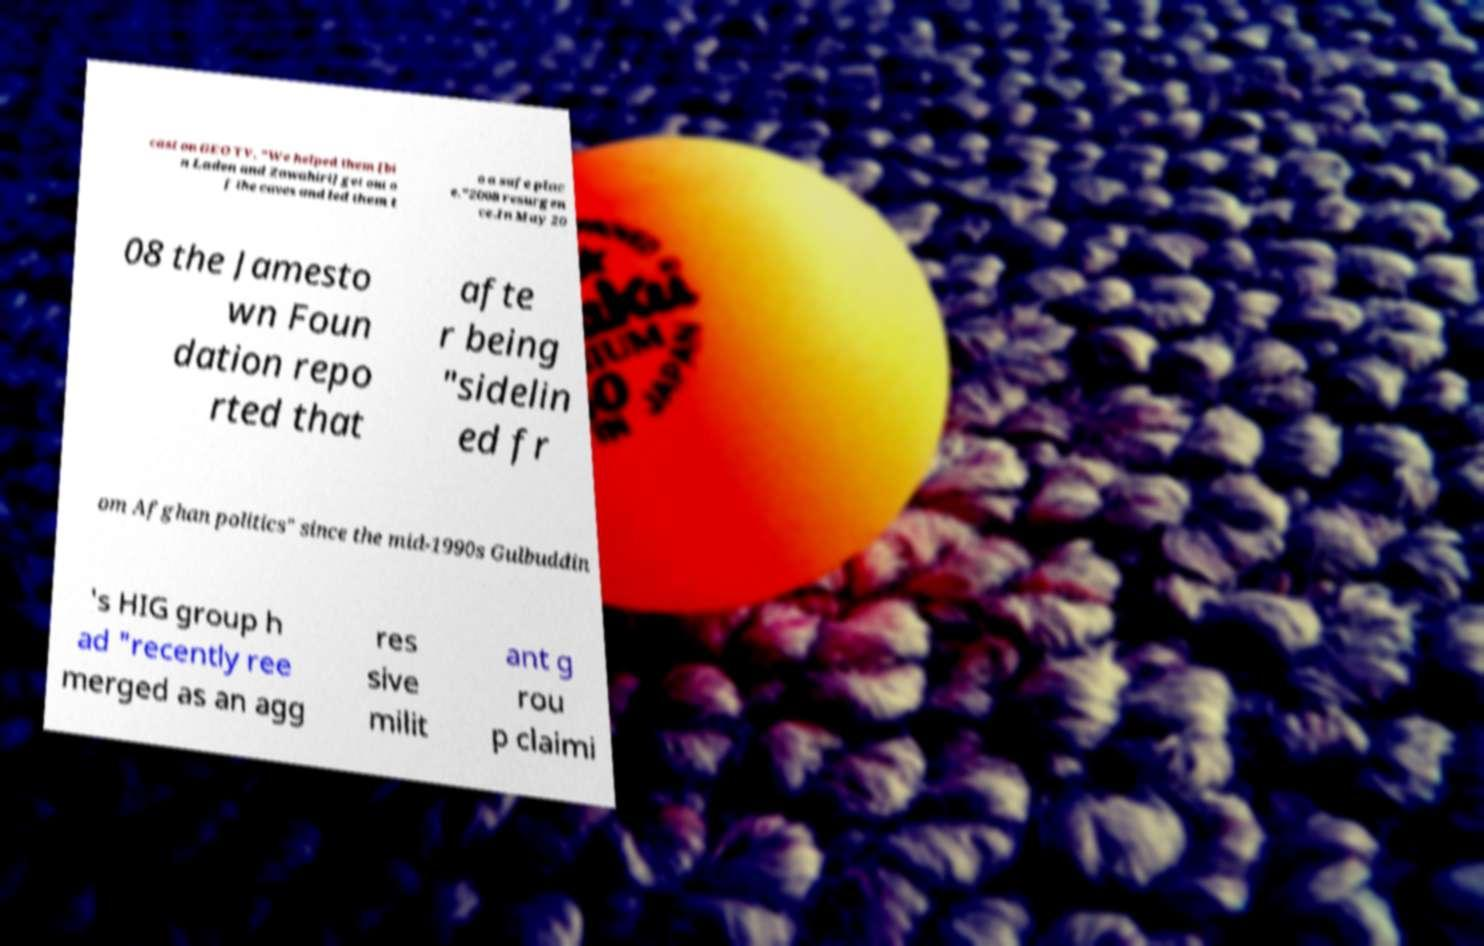Could you assist in decoding the text presented in this image and type it out clearly? cast on GEO TV, "We helped them [bi n Laden and Zawahiri] get out o f the caves and led them t o a safe plac e."2008 resurgen ce.In May 20 08 the Jamesto wn Foun dation repo rted that afte r being "sidelin ed fr om Afghan politics" since the mid-1990s Gulbuddin 's HIG group h ad "recently ree merged as an agg res sive milit ant g rou p claimi 